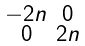Convert formula to latex. <formula><loc_0><loc_0><loc_500><loc_500>\begin{smallmatrix} - 2 n & 0 \\ 0 & 2 n \end{smallmatrix}</formula> 